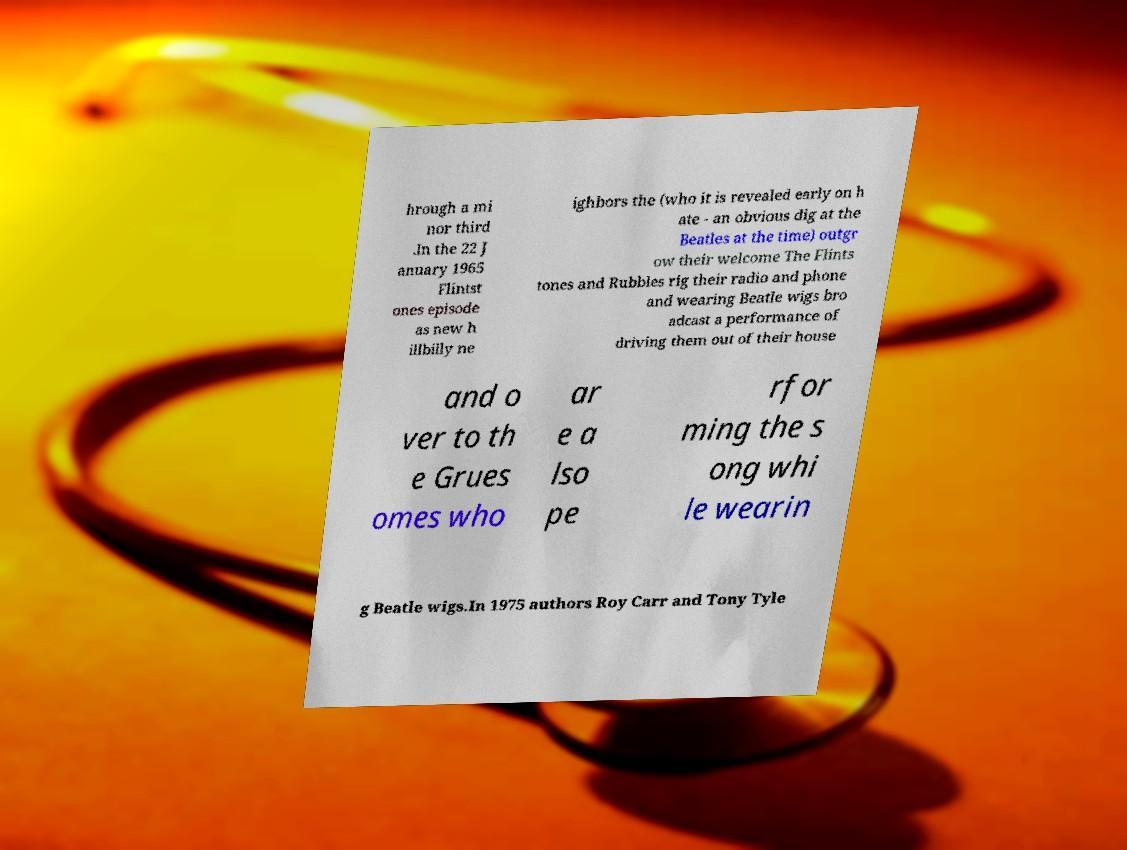Could you assist in decoding the text presented in this image and type it out clearly? hrough a mi nor third .In the 22 J anuary 1965 Flintst ones episode as new h illbilly ne ighbors the (who it is revealed early on h ate - an obvious dig at the Beatles at the time) outgr ow their welcome The Flints tones and Rubbles rig their radio and phone and wearing Beatle wigs bro adcast a performance of driving them out of their house and o ver to th e Grues omes who ar e a lso pe rfor ming the s ong whi le wearin g Beatle wigs.In 1975 authors Roy Carr and Tony Tyle 